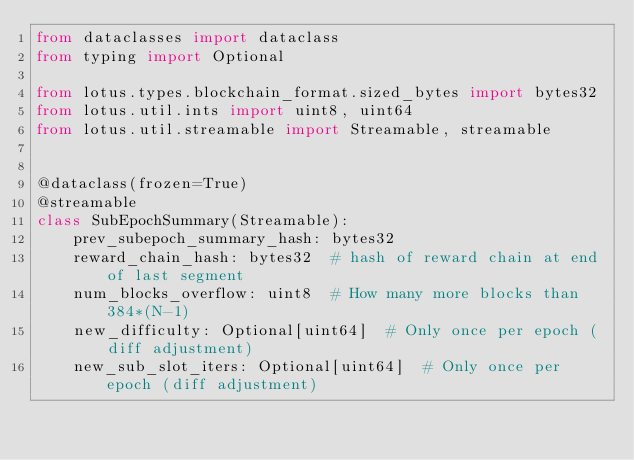Convert code to text. <code><loc_0><loc_0><loc_500><loc_500><_Python_>from dataclasses import dataclass
from typing import Optional

from lotus.types.blockchain_format.sized_bytes import bytes32
from lotus.util.ints import uint8, uint64
from lotus.util.streamable import Streamable, streamable


@dataclass(frozen=True)
@streamable
class SubEpochSummary(Streamable):
    prev_subepoch_summary_hash: bytes32
    reward_chain_hash: bytes32  # hash of reward chain at end of last segment
    num_blocks_overflow: uint8  # How many more blocks than 384*(N-1)
    new_difficulty: Optional[uint64]  # Only once per epoch (diff adjustment)
    new_sub_slot_iters: Optional[uint64]  # Only once per epoch (diff adjustment)
</code> 